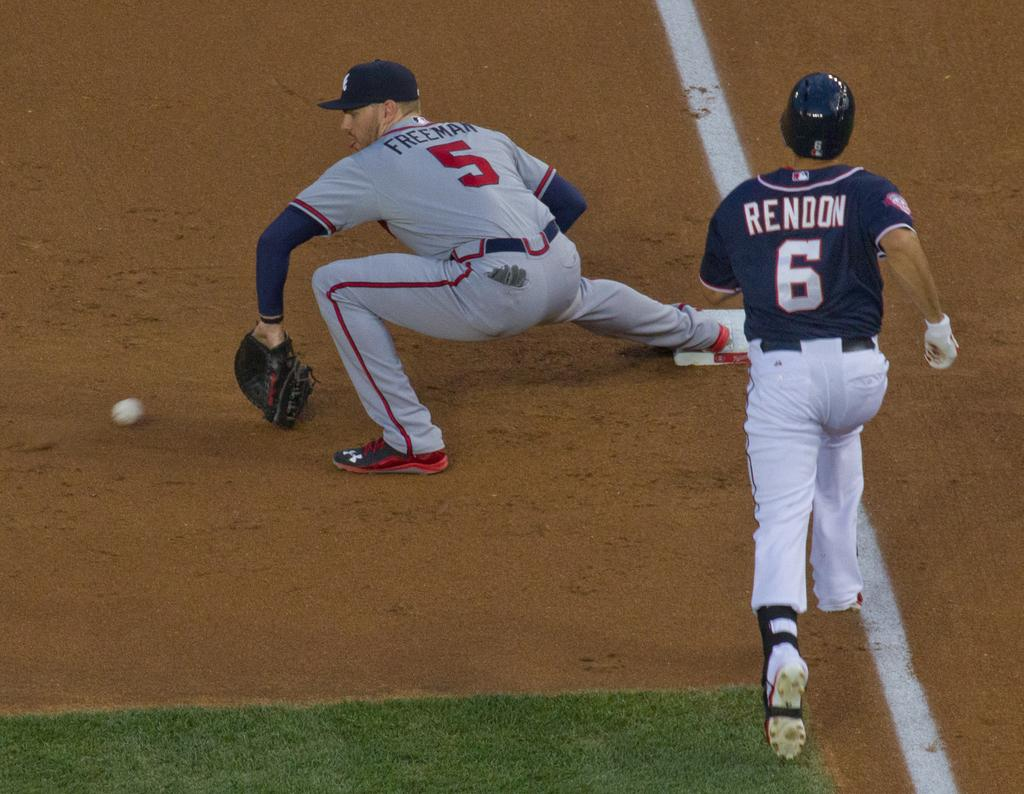<image>
Render a clear and concise summary of the photo. Rendon is wearing the number 6 jersey and making a run for it. 